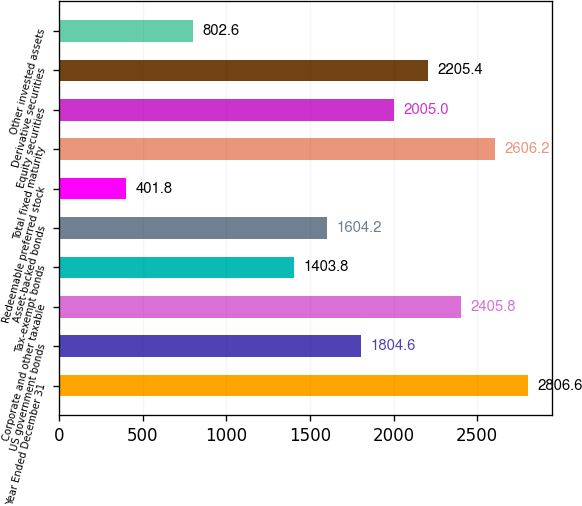Convert chart to OTSL. <chart><loc_0><loc_0><loc_500><loc_500><bar_chart><fcel>Year Ended December 31<fcel>US government bonds<fcel>Corporate and other taxable<fcel>Tax-exempt bonds<fcel>Asset-backed bonds<fcel>Redeemable preferred stock<fcel>Total fixed maturity<fcel>Equity securities<fcel>Derivative securities<fcel>Other invested assets<nl><fcel>2806.6<fcel>1804.6<fcel>2405.8<fcel>1403.8<fcel>1604.2<fcel>401.8<fcel>2606.2<fcel>2005<fcel>2205.4<fcel>802.6<nl></chart> 